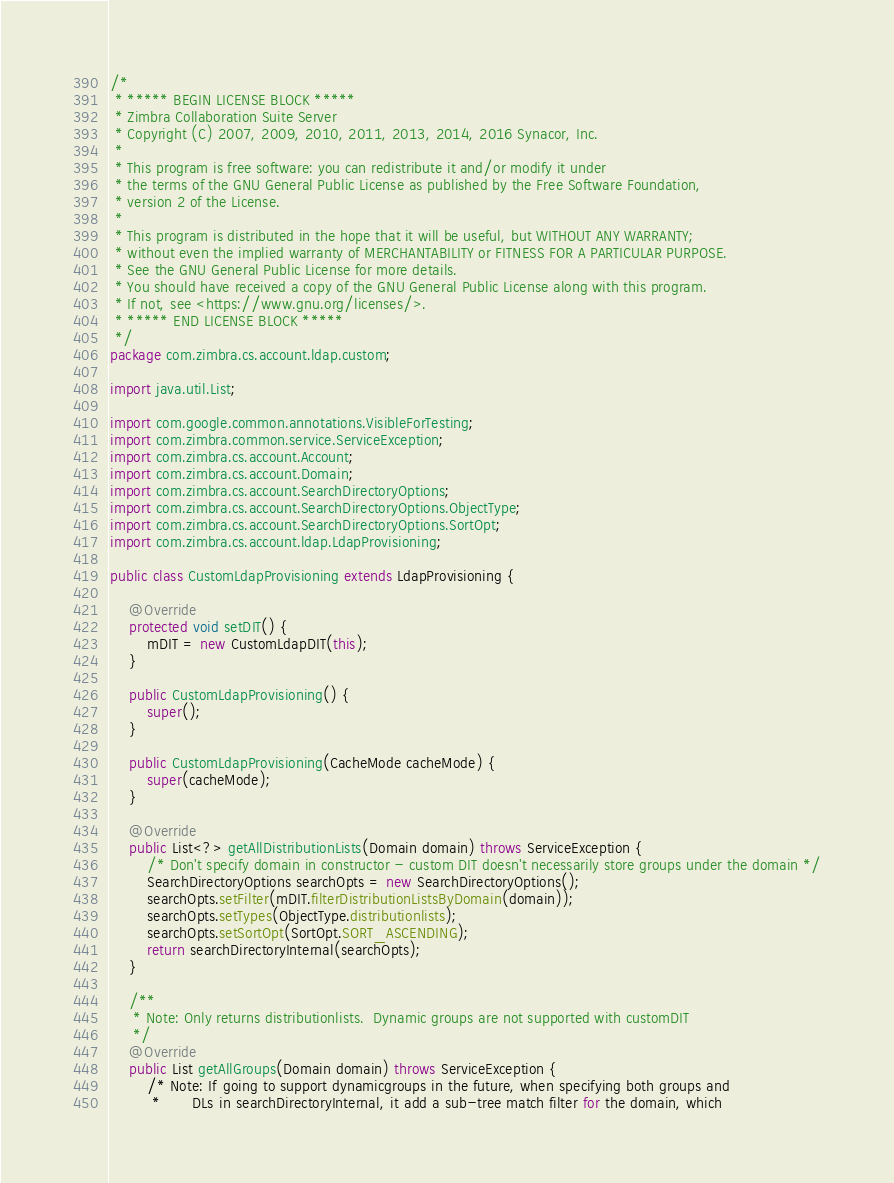Convert code to text. <code><loc_0><loc_0><loc_500><loc_500><_Java_>/*
 * ***** BEGIN LICENSE BLOCK *****
 * Zimbra Collaboration Suite Server
 * Copyright (C) 2007, 2009, 2010, 2011, 2013, 2014, 2016 Synacor, Inc.
 *
 * This program is free software: you can redistribute it and/or modify it under
 * the terms of the GNU General Public License as published by the Free Software Foundation,
 * version 2 of the License.
 *
 * This program is distributed in the hope that it will be useful, but WITHOUT ANY WARRANTY;
 * without even the implied warranty of MERCHANTABILITY or FITNESS FOR A PARTICULAR PURPOSE.
 * See the GNU General Public License for more details.
 * You should have received a copy of the GNU General Public License along with this program.
 * If not, see <https://www.gnu.org/licenses/>.
 * ***** END LICENSE BLOCK *****
 */
package com.zimbra.cs.account.ldap.custom;

import java.util.List;

import com.google.common.annotations.VisibleForTesting;
import com.zimbra.common.service.ServiceException;
import com.zimbra.cs.account.Account;
import com.zimbra.cs.account.Domain;
import com.zimbra.cs.account.SearchDirectoryOptions;
import com.zimbra.cs.account.SearchDirectoryOptions.ObjectType;
import com.zimbra.cs.account.SearchDirectoryOptions.SortOpt;
import com.zimbra.cs.account.ldap.LdapProvisioning;

public class CustomLdapProvisioning extends LdapProvisioning {

    @Override
    protected void setDIT() {
        mDIT = new CustomLdapDIT(this);
    }

    public CustomLdapProvisioning() {
        super();
    }

    public CustomLdapProvisioning(CacheMode cacheMode) {
        super(cacheMode);
    }

    @Override
    public List<?> getAllDistributionLists(Domain domain) throws ServiceException {
        /* Don't specify domain in constructor - custom DIT doesn't necessarily store groups under the domain */
        SearchDirectoryOptions searchOpts = new SearchDirectoryOptions();
        searchOpts.setFilter(mDIT.filterDistributionListsByDomain(domain));
        searchOpts.setTypes(ObjectType.distributionlists);
        searchOpts.setSortOpt(SortOpt.SORT_ASCENDING);
        return searchDirectoryInternal(searchOpts);
    }

    /**
     * Note: Only returns distributionlists.  Dynamic groups are not supported with customDIT
     */
    @Override
    public List getAllGroups(Domain domain) throws ServiceException {
        /* Note: If going to support dynamicgroups in the future, when specifying both groups and
         *       DLs in searchDirectoryInternal, it add a sub-tree match filter for the domain, which</code> 